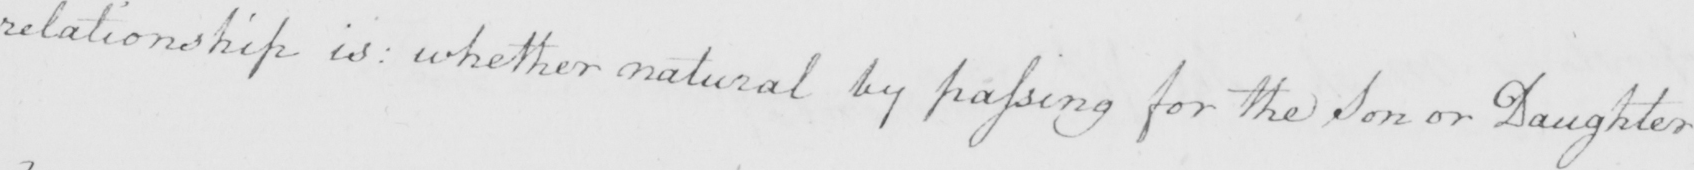Can you tell me what this handwritten text says? relationship is :  whether natural by passing for the Son or Daughter 